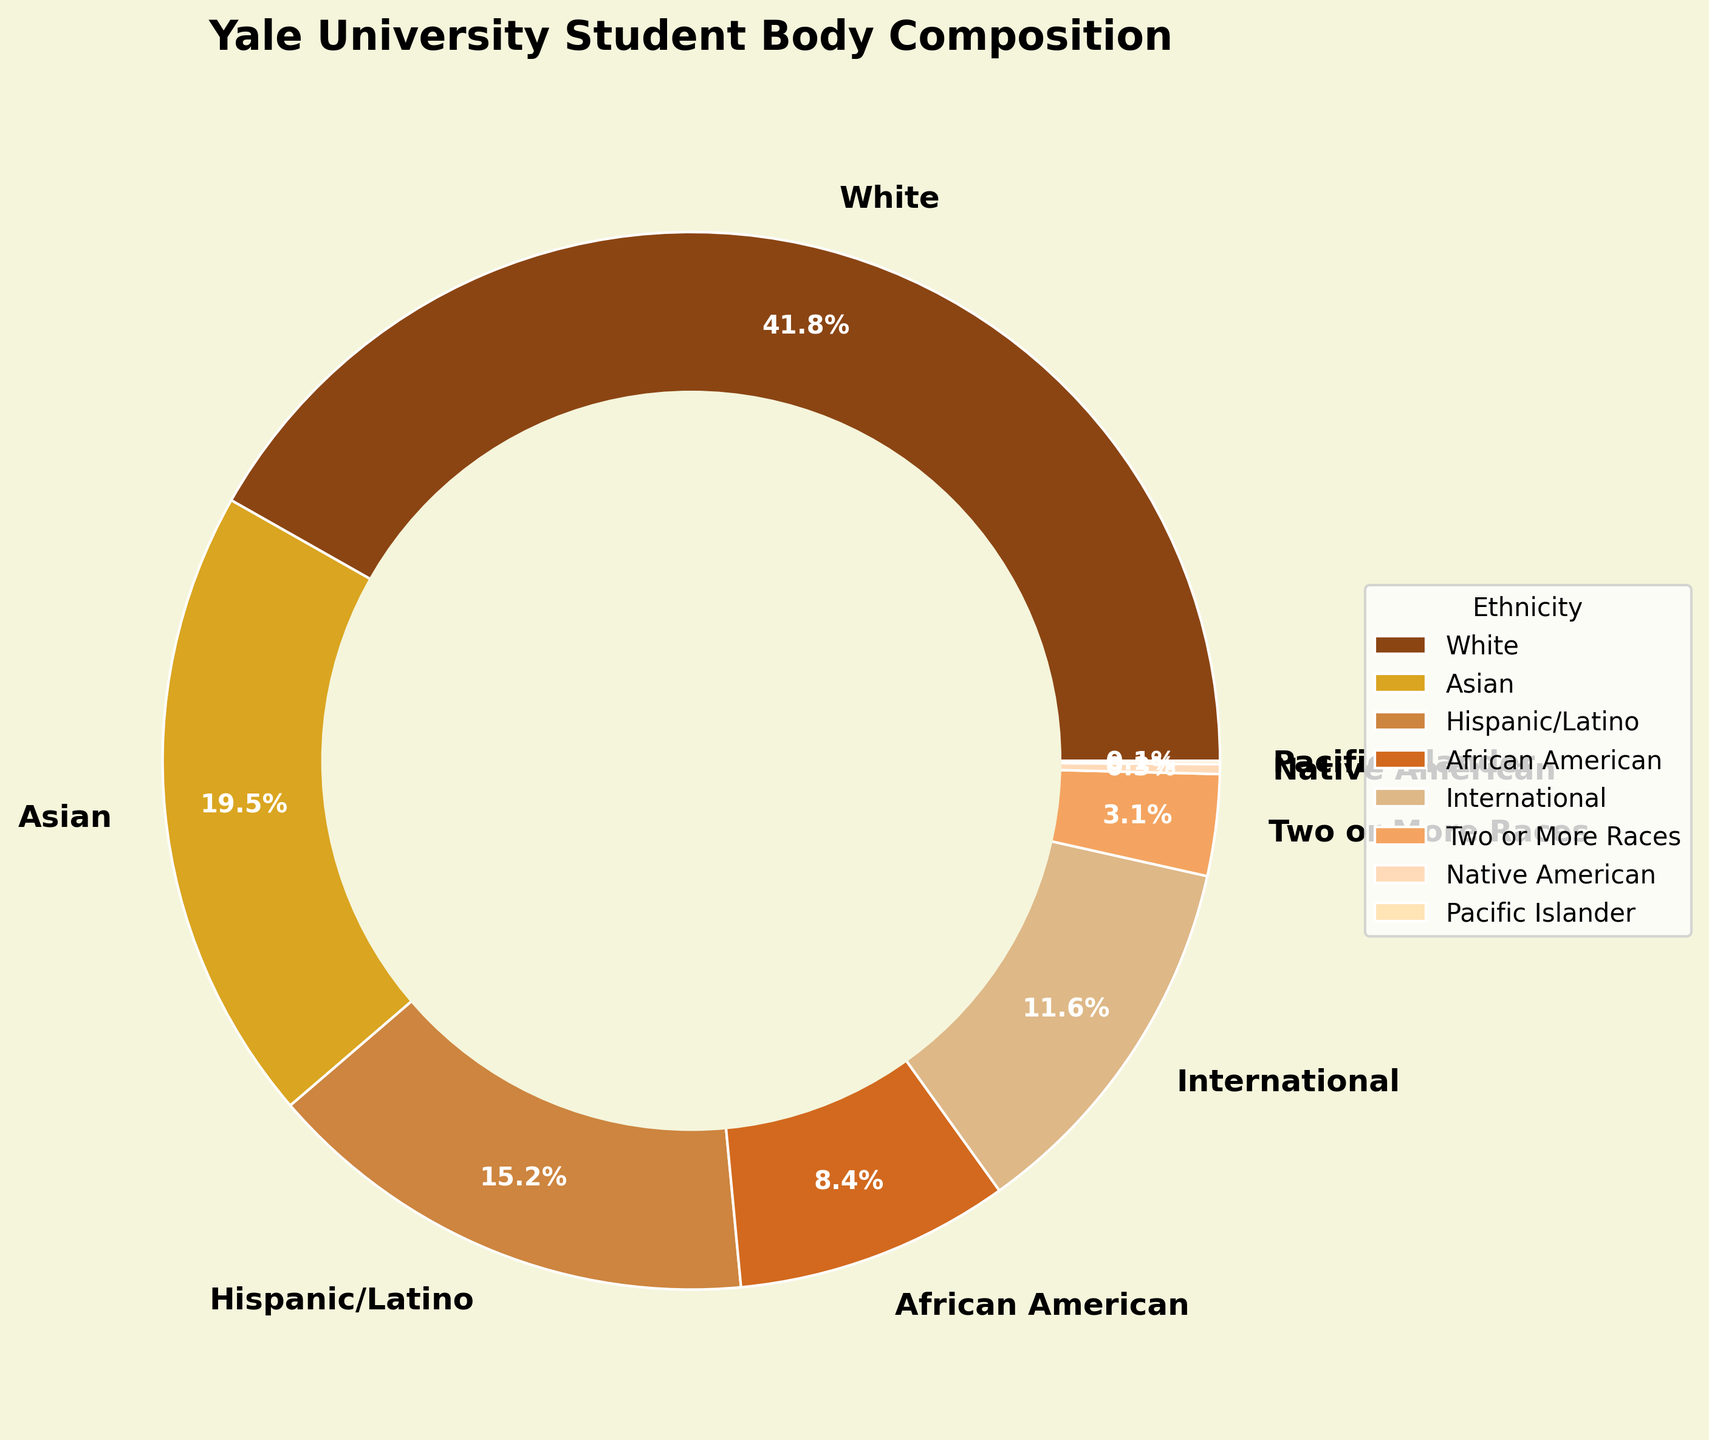Which ethnic group has the highest percentage in Yale's student body composition? The pie chart shows different percentages for each ethnic group. By visual inspection, the slice labeled "White" occupies the largest portion.
Answer: White What is the combined percentage of Hispanic/Latino and African American students? First, identify the percentages for Hispanic/Latino and African American students (15.2% and 8.4%, respectively). Then, add these values together: 15.2 + 8.4 = 23.6.
Answer: 23.6% How much greater is the percentage of Asian students compared to the percentage of Native American students? Identify the percentages for Asian and Native American students (19.5% and 0.3%). Subtract the smaller value from the larger value: 19.5 - 0.3 = 19.2.
Answer: 19.2% Which group has the lowest percentage, and what is that percentage? The pie chart has labels for each ethnic group with their respective percentages. The smallest slice represents the "Pacific Islander" group, showing a value of 0.1%.
Answer: Pacific Islander, 0.1% What is the difference in percentage between International and Two or More Races students? Identify the percentages for International and Two or More Races students (11.6% and 3.1%). Subtract the smaller value from the larger one: 11.6 - 3.1 = 8.5.
Answer: 8.5% Rank the top three ethnic groups by their percentage from highest to lowest. Look at each slice and their respective percentages on the pie chart. The top three groups are: White (41.8%), Asian (19.5%), and Hispanic/Latino (15.2%).
Answer: White, Asian, Hispanic/Latino By what percentage does the White student body exceed the International and Hispanic/Latino combined? First, sum the percentages of International and Hispanic/Latino students: 11.6% + 15.2% = 26.8%. Then, identify the percentage for White students (41.8%). Subtract the sum you calculated: 41.8 - 26.8 = 15%.
Answer: 15% Which ethnicities have a combined student body percentage that is under 5%? Identify the percentages of each ethnicity and combine those below 5%: Two or More Races (3.1%), Native American (0.3%), and Pacific Islander (0.1%). Adding these up: 3.1 + 0.3 + 0.1 = 3.5%.
Answer: Two or More Races, Native American, Pacific Islander What is the median percentage if you list all the ethnicities by their student body percentages? The percentages in ascending order are: 0.1%, 0.3%, 3.1%, 8.4%, 11.6%, 15.2%, 19.5%, 41.8%. The median is the average of the middle two values (8.4% and 11.6%): (8.4 + 11.6)/2 = 10.
Answer: 10% 